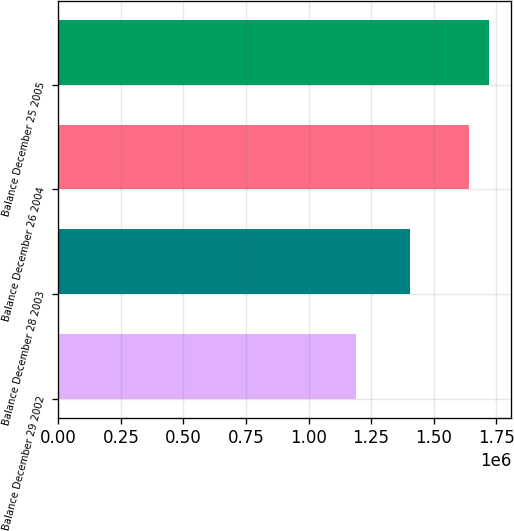Convert chart to OTSL. <chart><loc_0><loc_0><loc_500><loc_500><bar_chart><fcel>Balance December 29 2002<fcel>Balance December 28 2003<fcel>Balance December 26 2004<fcel>Balance December 25 2005<nl><fcel>1.19137e+06<fcel>1.40524e+06<fcel>1.63972e+06<fcel>1.72348e+06<nl></chart> 